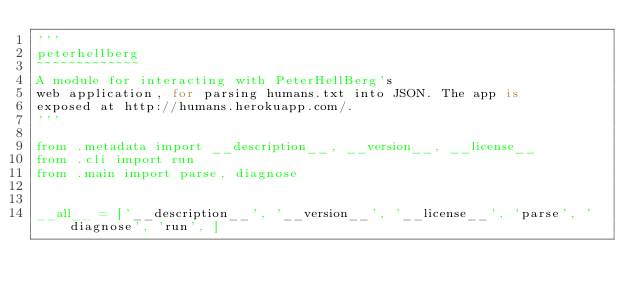<code> <loc_0><loc_0><loc_500><loc_500><_Python_>'''
peterhellberg
~~~~~~~~~~~~~
A module for interacting with PeterHellBerg's
web application, for parsing humans.txt into JSON. The app is
exposed at http://humans.herokuapp.com/.
'''

from .metadata import __description__, __version__, __license__
from .cli import run
from .main import parse, diagnose


__all__ = ['__description__', '__version__', '__license__', 'parse', 'diagnose', 'run', ]
</code> 